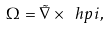Convert formula to latex. <formula><loc_0><loc_0><loc_500><loc_500>\Omega = \tilde { \nabla } \times \ h p i ,</formula> 